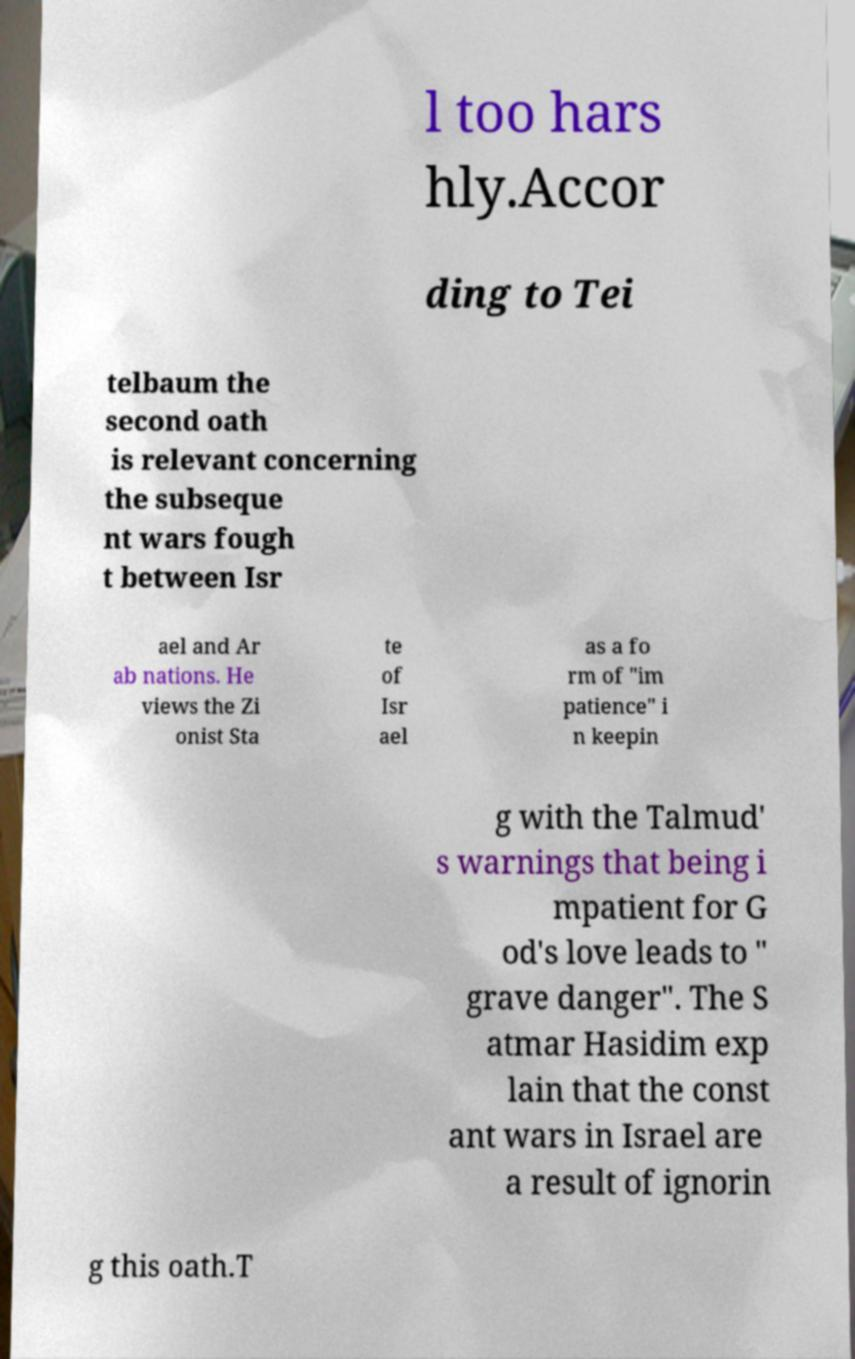There's text embedded in this image that I need extracted. Can you transcribe it verbatim? l too hars hly.Accor ding to Tei telbaum the second oath is relevant concerning the subseque nt wars fough t between Isr ael and Ar ab nations. He views the Zi onist Sta te of Isr ael as a fo rm of "im patience" i n keepin g with the Talmud' s warnings that being i mpatient for G od's love leads to " grave danger". The S atmar Hasidim exp lain that the const ant wars in Israel are a result of ignorin g this oath.T 